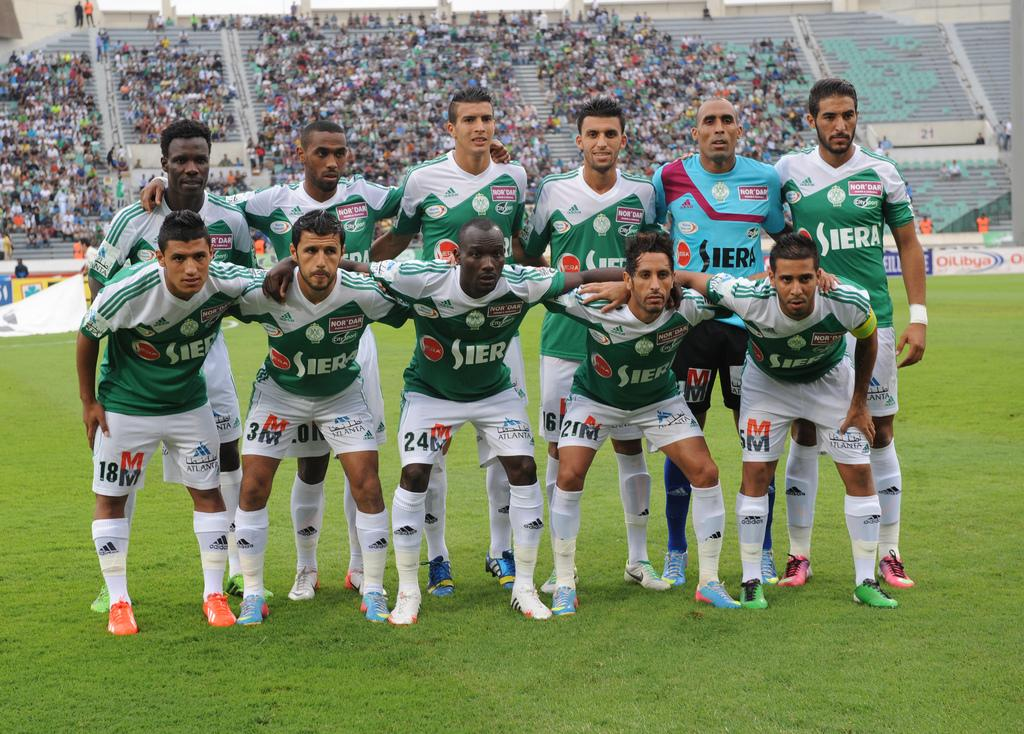<image>
Describe the image concisely. The Siera team lines up for a team photo on the field. 